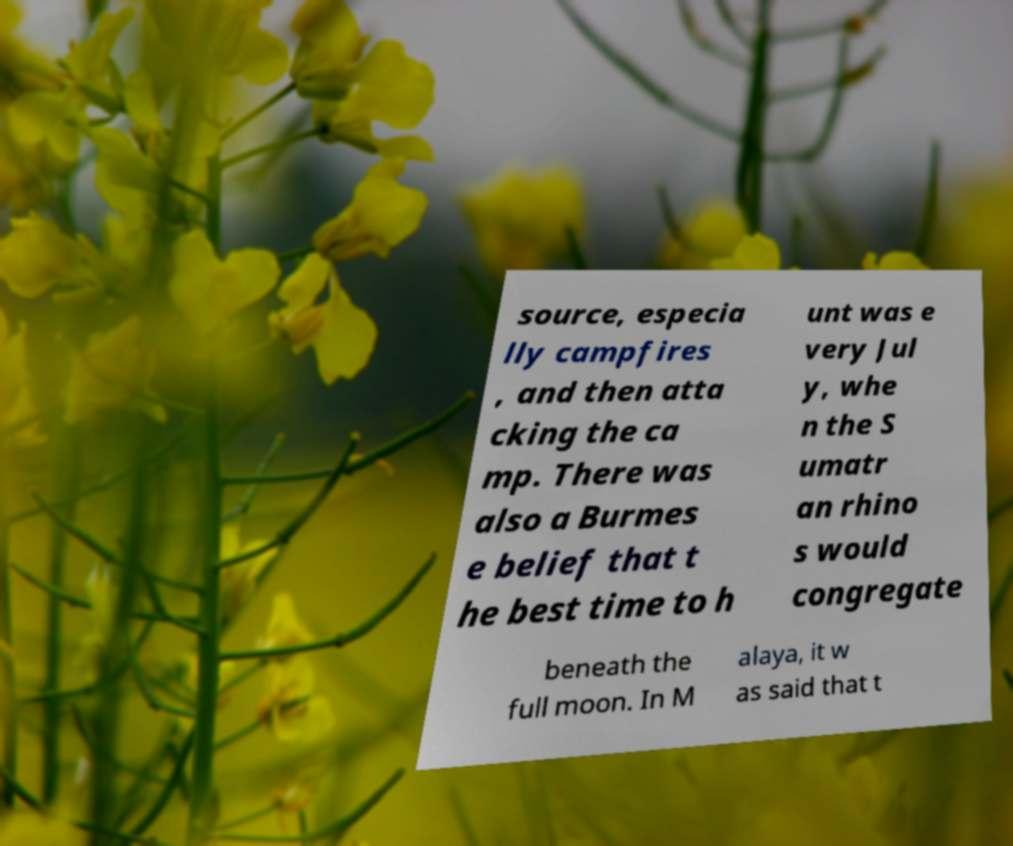Can you accurately transcribe the text from the provided image for me? source, especia lly campfires , and then atta cking the ca mp. There was also a Burmes e belief that t he best time to h unt was e very Jul y, whe n the S umatr an rhino s would congregate beneath the full moon. In M alaya, it w as said that t 